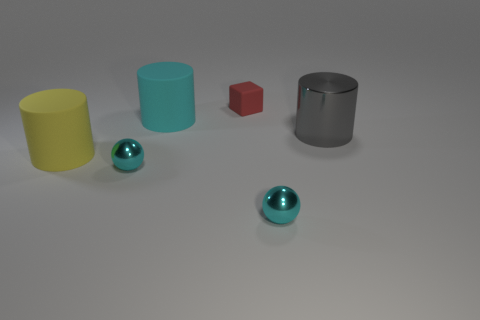There is a cyan object that is behind the big yellow cylinder; does it have the same shape as the small cyan thing that is on the left side of the tiny cube?
Offer a terse response. No. What number of balls are either large cyan things or tiny green shiny things?
Your answer should be very brief. 0. What is the cyan sphere that is behind the tiny cyan metal sphere in front of the sphere that is on the left side of the red matte block made of?
Make the answer very short. Metal. How many other things are the same size as the gray thing?
Your answer should be very brief. 2. Is the number of tiny cyan metallic spheres that are behind the yellow matte cylinder greater than the number of big things?
Ensure brevity in your answer.  No. Are there any rubber cylinders that have the same color as the block?
Ensure brevity in your answer.  No. What is the color of the other shiny cylinder that is the same size as the cyan cylinder?
Your response must be concise. Gray. There is a big yellow matte object that is left of the cyan matte cylinder; what number of cyan things are in front of it?
Your response must be concise. 2. What number of things are metallic objects to the left of the cyan cylinder or blue cylinders?
Ensure brevity in your answer.  1. How many large yellow things are the same material as the small red object?
Provide a short and direct response. 1. 